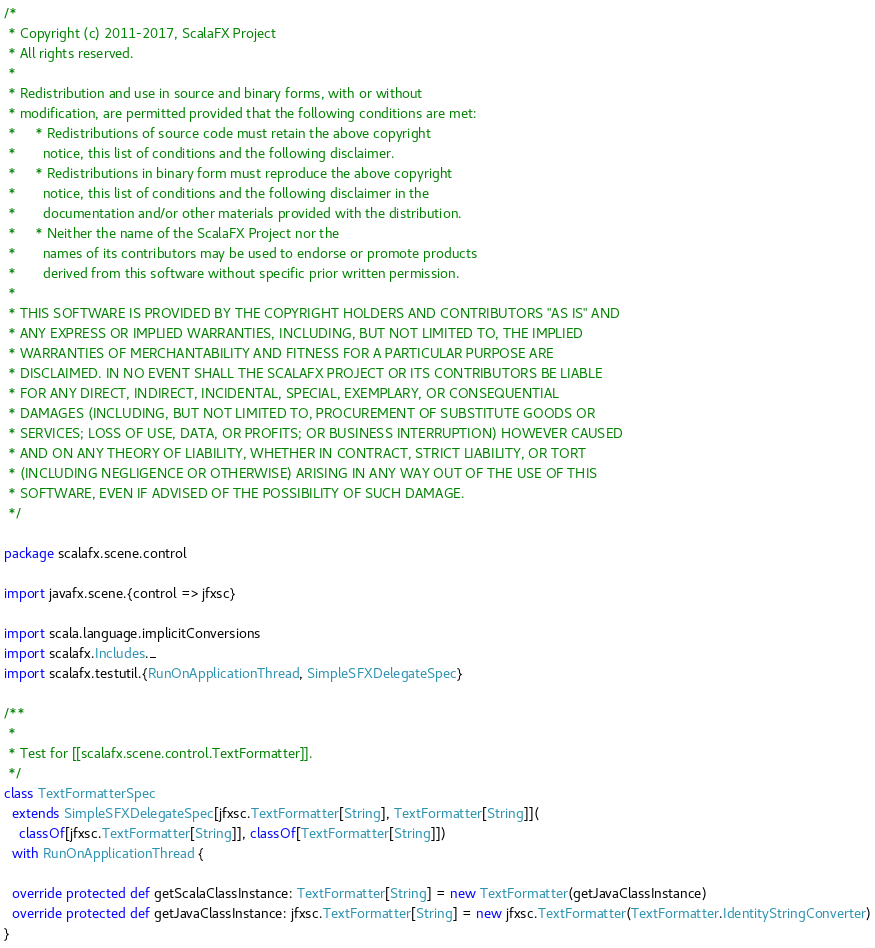<code> <loc_0><loc_0><loc_500><loc_500><_Scala_>/*
 * Copyright (c) 2011-2017, ScalaFX Project
 * All rights reserved.
 *
 * Redistribution and use in source and binary forms, with or without
 * modification, are permitted provided that the following conditions are met:
 *     * Redistributions of source code must retain the above copyright
 *       notice, this list of conditions and the following disclaimer.
 *     * Redistributions in binary form must reproduce the above copyright
 *       notice, this list of conditions and the following disclaimer in the
 *       documentation and/or other materials provided with the distribution.
 *     * Neither the name of the ScalaFX Project nor the
 *       names of its contributors may be used to endorse or promote products
 *       derived from this software without specific prior written permission.
 *
 * THIS SOFTWARE IS PROVIDED BY THE COPYRIGHT HOLDERS AND CONTRIBUTORS "AS IS" AND
 * ANY EXPRESS OR IMPLIED WARRANTIES, INCLUDING, BUT NOT LIMITED TO, THE IMPLIED
 * WARRANTIES OF MERCHANTABILITY AND FITNESS FOR A PARTICULAR PURPOSE ARE
 * DISCLAIMED. IN NO EVENT SHALL THE SCALAFX PROJECT OR ITS CONTRIBUTORS BE LIABLE
 * FOR ANY DIRECT, INDIRECT, INCIDENTAL, SPECIAL, EXEMPLARY, OR CONSEQUENTIAL
 * DAMAGES (INCLUDING, BUT NOT LIMITED TO, PROCUREMENT OF SUBSTITUTE GOODS OR
 * SERVICES; LOSS OF USE, DATA, OR PROFITS; OR BUSINESS INTERRUPTION) HOWEVER CAUSED
 * AND ON ANY THEORY OF LIABILITY, WHETHER IN CONTRACT, STRICT LIABILITY, OR TORT
 * (INCLUDING NEGLIGENCE OR OTHERWISE) ARISING IN ANY WAY OUT OF THE USE OF THIS
 * SOFTWARE, EVEN IF ADVISED OF THE POSSIBILITY OF SUCH DAMAGE.
 */

package scalafx.scene.control

import javafx.scene.{control => jfxsc}

import scala.language.implicitConversions
import scalafx.Includes._
import scalafx.testutil.{RunOnApplicationThread, SimpleSFXDelegateSpec}

/**
 *
 * Test for [[scalafx.scene.control.TextFormatter]].
 */
class TextFormatterSpec
  extends SimpleSFXDelegateSpec[jfxsc.TextFormatter[String], TextFormatter[String]](
    classOf[jfxsc.TextFormatter[String]], classOf[TextFormatter[String]])
  with RunOnApplicationThread {

  override protected def getScalaClassInstance: TextFormatter[String] = new TextFormatter(getJavaClassInstance)
  override protected def getJavaClassInstance: jfxsc.TextFormatter[String] = new jfxsc.TextFormatter(TextFormatter.IdentityStringConverter)
}</code> 